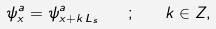Convert formula to latex. <formula><loc_0><loc_0><loc_500><loc_500>\psi ^ { a } _ { x } = \psi ^ { a } _ { x + k \, L _ { s } } \quad ; \quad k \in Z ,</formula> 